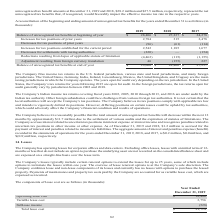According to Aci Worldwide's financial document, What was the balance of unrecognized tax benefits at the beginning of 2019? According to the financial document, $28,406 (in thousands). The relevant text states: "unrecognized tax benefits at beginning of year $ 28,406 $ 27,237 $ 24,278..." Also, What was the balance of unrecognized tax benefits at the beginning of 2017? According to the financial document, $24,278 (in thousands). The relevant text states: "benefits at beginning of year $ 28,406 $ 27,237 $ 24,278..." Also, What was the increases for tax positions of prior years in 2019? According to the financial document, 2,784 (in thousands). The relevant text states: "Increases for tax positions of prior years 2,784 315 2,478..." Also, can you calculate: What was the change in Balance of unrecognized tax benefits at beginning of year between 2017 and 2018? Based on the calculation: $27,237-$24,278, the result is 2959 (in thousands). This is based on the information: "benefits at beginning of year $ 28,406 $ 27,237 $ 24,278 ized tax benefits at beginning of year $ 28,406 $ 27,237 $ 24,278..." The key data points involved are: 24,278, 27,237. Also, can you calculate: What was the change in balance of unrecognized tax benefits at the end of the year between 2018 and 2019? Based on the calculation: $29,000-$28,406, the result is 594 (in thousands). This is based on the information: "nce of unrecognized tax benefits at end of year $ 29,000 $ 28,406 $ 27,237 unrecognized tax benefits at beginning of year $ 28,406 $ 27,237 $ 24,278..." The key data points involved are: 28,406, 29,000. Also, can you calculate: What was the percentage change in increases for tax positions established for the current year between 2018 and 2019? To answer this question, I need to perform calculations using the financial data. The calculation is: (2,542-1,185)/1,185, which equals 114.51 (percentage). This is based on the information: "tax positions established for the current period 2,542 1,185 1,677 ositions established for the current period 2,542 1,185 1,677..." The key data points involved are: 1,185, 2,542. 